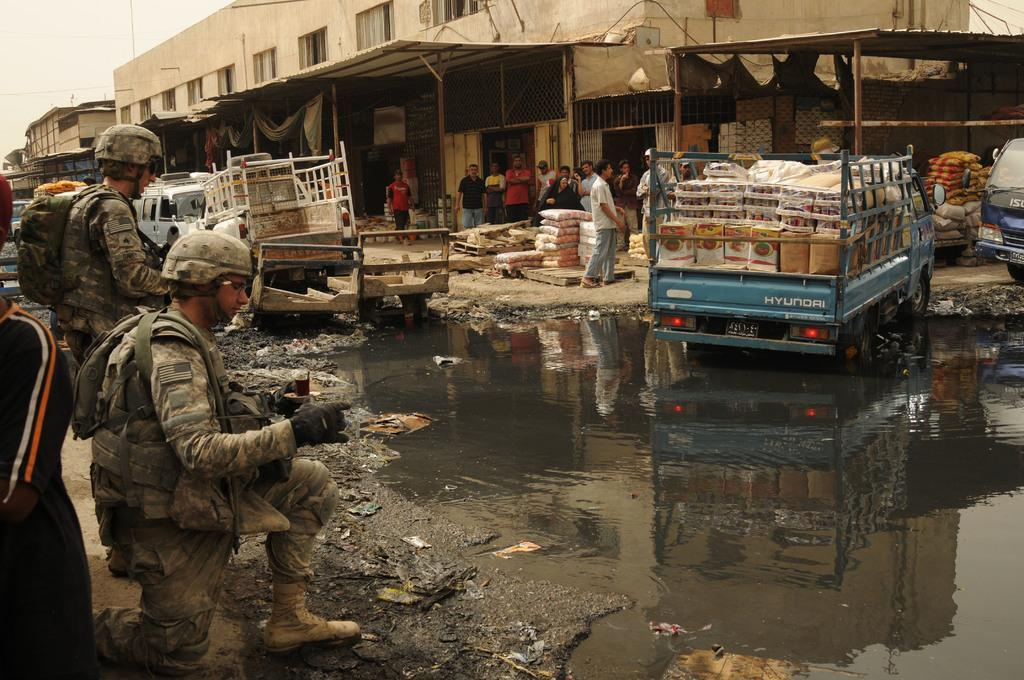What types of vehicles are in the image? There are motor vehicles in the image. What can be seen near the vehicles? There are grills and poles in the image. What type of structures are present in the image? There are sheds in the image. What is the condition of the people in the image? There are persons on the ground in the image. What natural element is visible in the image? There is water visible in the image. What type of pest can be seen crawling on the grass in the image? There is no grass present in the image, and therefore no pests can be observed. Who is the friend of the person standing near the shed in the image? There is no information about friends or relationships in the image. 